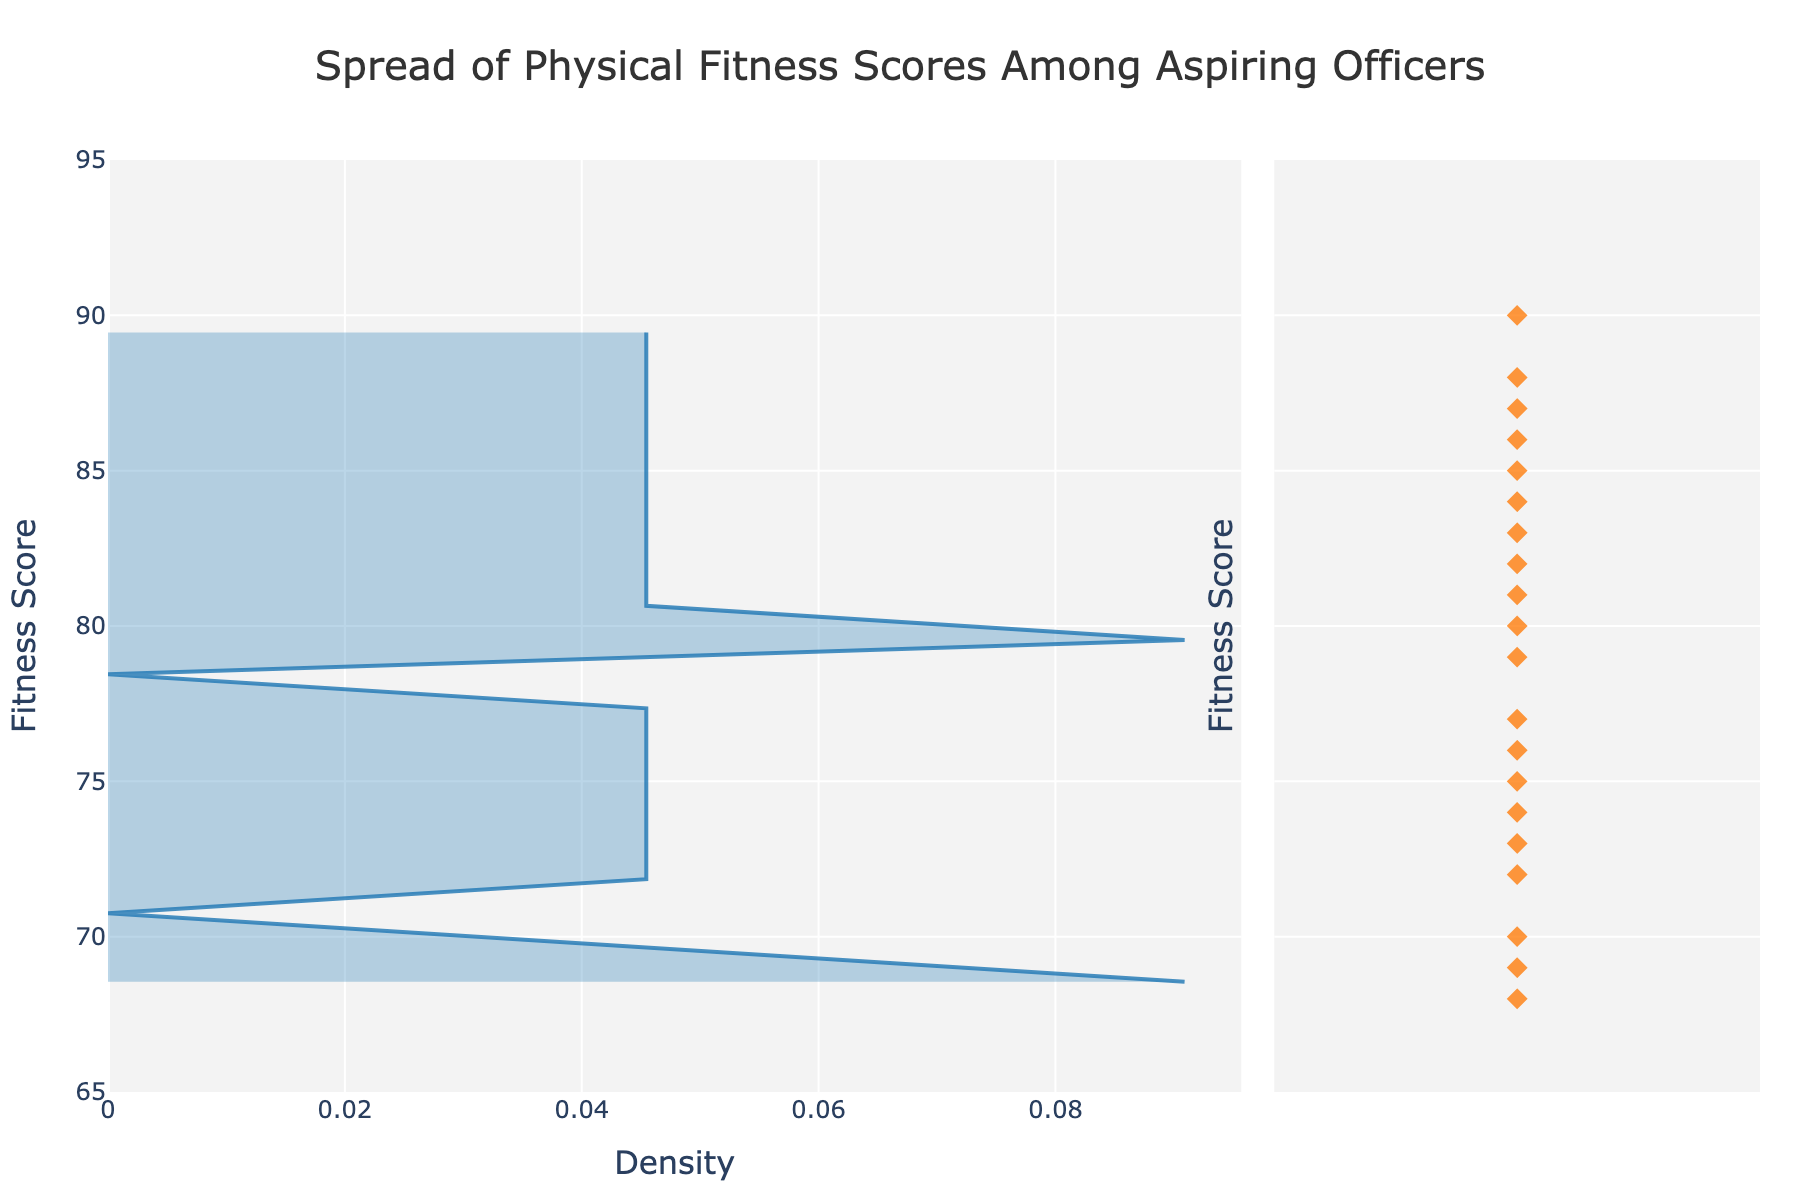What is the title of the figure? The title is usually placed at the top of the figure. From the visual information, it appears as "Spread of Physical Fitness Scores Among Aspiring Officers".
Answer: Spread of Physical Fitness Scores Among Aspiring Officers What is the range of fitness scores shown on the y-axis? Observe the y-axis on the left side of the figure. It starts at 65 and ends at 95. This represents the range of fitness scores.
Answer: 65 to 95 Where is the peak density of results located? Look at the horizontal density plot where the curve reaches its maximum height. This appears to be around the fitness score of 80.
Answer: Around 80 How many individual sailor points are displayed in the right subplot? Count the number of points in the right subplot. There are 20 sailors’ scores displayed.
Answer: 20 Which sailor has the highest fitness score and what is the score? Hover over the highest point among the individual scores on the right subplot. This is for James O'Connor with a score of 90.
Answer: James O'Connor, 90 How many sailors have a fitness score of 80 or above? Count the individual sailors' scores on the right subplot that are at or above 80. There are 12 sailors with scores of 80 or higher.
Answer: 12 What is the estimated median fitness score from the density plot? The median is where half the observations are above and half are below. From the density plot, the score closest to the 50th percentile seems to be around 78-79.
Answer: Around 78-79 Compare the density around fitness scores 70 and 85. Which is denser? Look at the heights of the density plot around these scores. The height is greater around 85 compared to 70, indicating higher density.
Answer: 85 is denser What is the color of the individual sailor points? Observe the color of the markers in the subplot containing the individual sailor points. They appear to be orange.
Answer: Orange What proportion of sailors have fitness scores between 70 and 80? Count the points between these two scores and divide by the total number of points. There are 9 out of 20 sailors in this range. Thus, the proportion is 9/20 or 45%.
Answer: 45% 